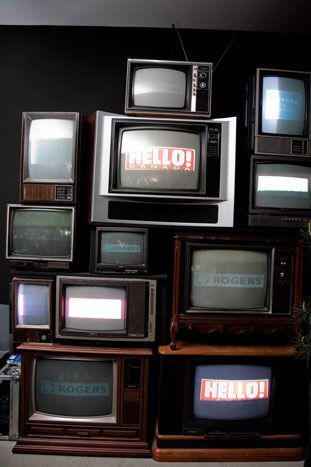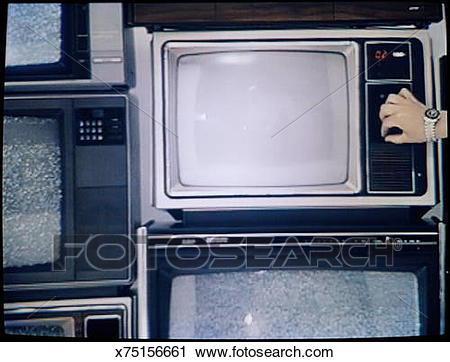The first image is the image on the left, the second image is the image on the right. Analyze the images presented: Is the assertion "Each image shows stacks of different model old-fashioned TV sets, and the right image includes some TVs with static on the screens." valid? Answer yes or no. Yes. 